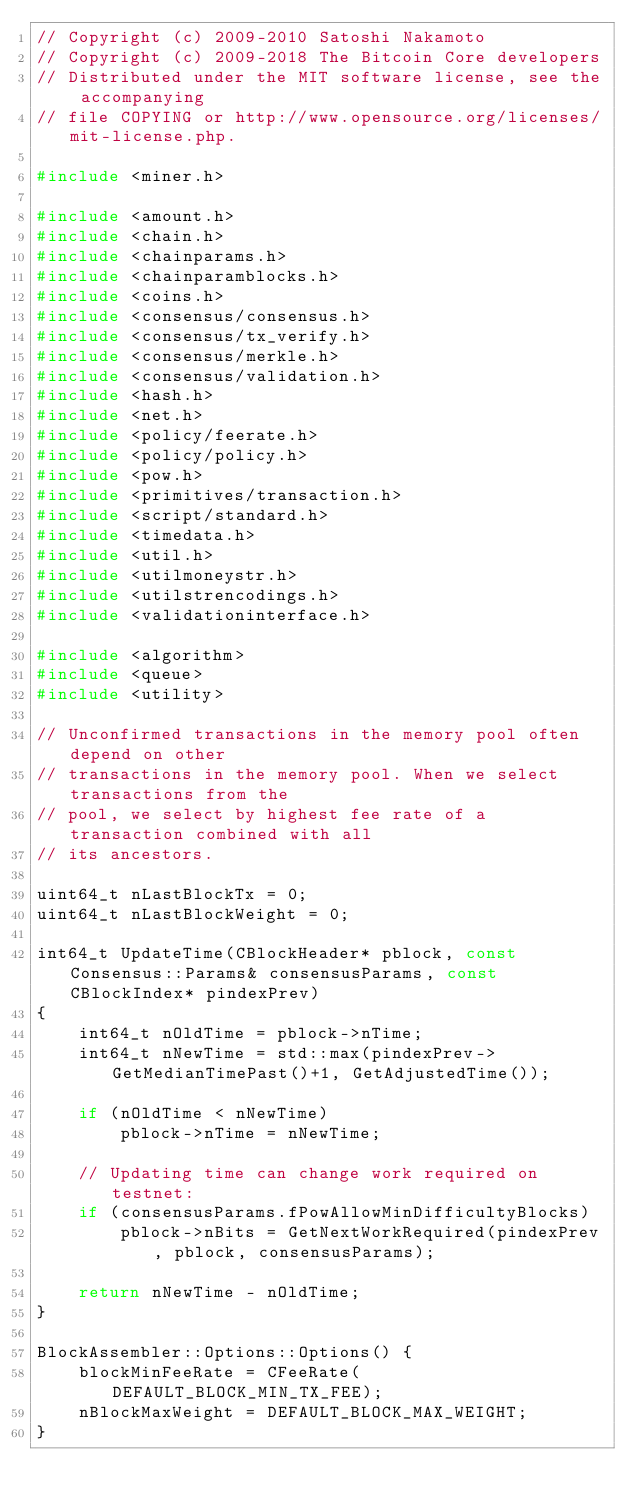Convert code to text. <code><loc_0><loc_0><loc_500><loc_500><_C++_>// Copyright (c) 2009-2010 Satoshi Nakamoto
// Copyright (c) 2009-2018 The Bitcoin Core developers
// Distributed under the MIT software license, see the accompanying
// file COPYING or http://www.opensource.org/licenses/mit-license.php.

#include <miner.h>

#include <amount.h>
#include <chain.h>
#include <chainparams.h>
#include <chainparamblocks.h>
#include <coins.h>
#include <consensus/consensus.h>
#include <consensus/tx_verify.h>
#include <consensus/merkle.h>
#include <consensus/validation.h>
#include <hash.h>
#include <net.h>
#include <policy/feerate.h>
#include <policy/policy.h>
#include <pow.h>
#include <primitives/transaction.h>
#include <script/standard.h>
#include <timedata.h>
#include <util.h>
#include <utilmoneystr.h>
#include <utilstrencodings.h>
#include <validationinterface.h>

#include <algorithm>
#include <queue>
#include <utility>

// Unconfirmed transactions in the memory pool often depend on other
// transactions in the memory pool. When we select transactions from the
// pool, we select by highest fee rate of a transaction combined with all
// its ancestors.

uint64_t nLastBlockTx = 0;
uint64_t nLastBlockWeight = 0;

int64_t UpdateTime(CBlockHeader* pblock, const Consensus::Params& consensusParams, const CBlockIndex* pindexPrev)
{
    int64_t nOldTime = pblock->nTime;
    int64_t nNewTime = std::max(pindexPrev->GetMedianTimePast()+1, GetAdjustedTime());

    if (nOldTime < nNewTime)
        pblock->nTime = nNewTime;

    // Updating time can change work required on testnet:
    if (consensusParams.fPowAllowMinDifficultyBlocks)
        pblock->nBits = GetNextWorkRequired(pindexPrev, pblock, consensusParams);

    return nNewTime - nOldTime;
}

BlockAssembler::Options::Options() {
    blockMinFeeRate = CFeeRate(DEFAULT_BLOCK_MIN_TX_FEE);
    nBlockMaxWeight = DEFAULT_BLOCK_MAX_WEIGHT;
}
</code> 